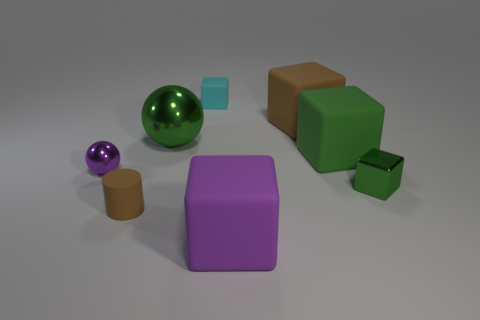Is the big sphere the same color as the metallic block?
Your response must be concise. Yes. The tiny cylinder that is the same material as the brown block is what color?
Provide a succinct answer. Brown. Is the number of green rubber blocks in front of the tiny green shiny object less than the number of purple things left of the cyan cube?
Offer a terse response. Yes. There is a matte block that is in front of the small green shiny object; is its color the same as the sphere that is in front of the big green metal thing?
Your answer should be very brief. Yes. Are there any other things that have the same material as the small green thing?
Your answer should be very brief. Yes. What is the size of the purple thing in front of the tiny shiny thing that is to the left of the small green cube?
Your response must be concise. Large. Is the number of large green cylinders greater than the number of large matte cubes?
Your answer should be very brief. No. There is a sphere that is on the right side of the purple sphere; is it the same size as the small brown cylinder?
Make the answer very short. No. What number of small metallic objects are the same color as the big metallic sphere?
Give a very brief answer. 1. Is the shape of the tiny purple metallic thing the same as the small cyan rubber object?
Keep it short and to the point. No. 